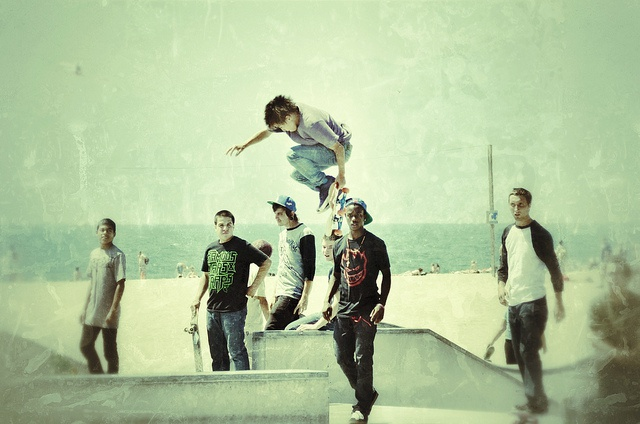Describe the objects in this image and their specific colors. I can see people in lightgreen, black, beige, and gray tones, people in lightgreen, black, gray, beige, and darkgray tones, people in lightgreen, darkgreen, gray, and darkgray tones, people in lightgreen, black, gray, olive, and beige tones, and people in lightgreen, darkgray, gray, lightyellow, and beige tones in this image. 